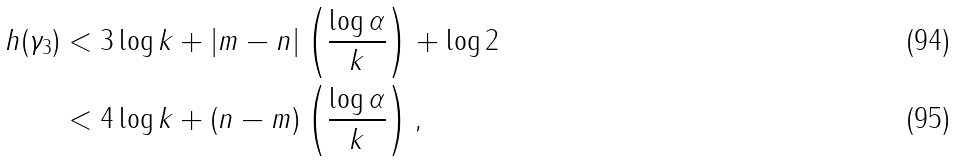Convert formula to latex. <formula><loc_0><loc_0><loc_500><loc_500>h ( \gamma _ { 3 } ) & < 3 \log k + | m - n | \left ( \frac { \log \alpha } { k } \right ) + \log 2 \\ & < 4 \log k + ( n - m ) \left ( \frac { \log \alpha } { k } \right ) ,</formula> 